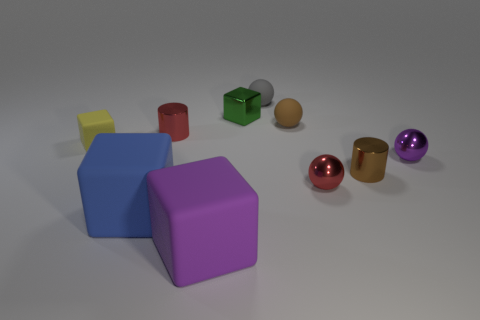What is the material of the big blue thing?
Ensure brevity in your answer.  Rubber. What material is the purple object left of the gray rubber sphere?
Ensure brevity in your answer.  Rubber. What is the material of the purple object that is the same size as the green metal thing?
Make the answer very short. Metal. Do the brown object that is in front of the yellow rubber cube and the rubber object in front of the blue rubber object have the same size?
Provide a succinct answer. No. How many things are either tiny red shiny spheres or red things to the right of the large purple thing?
Your answer should be very brief. 1. Is there a small purple shiny thing of the same shape as the big purple thing?
Provide a short and direct response. No. There is a purple object that is to the left of the small matte ball that is behind the small green object; what size is it?
Keep it short and to the point. Large. What number of rubber things are red spheres or tiny purple objects?
Provide a short and direct response. 0. How many red things are there?
Offer a very short reply. 2. Does the sphere left of the brown rubber ball have the same material as the small brown thing that is in front of the red cylinder?
Offer a very short reply. No. 